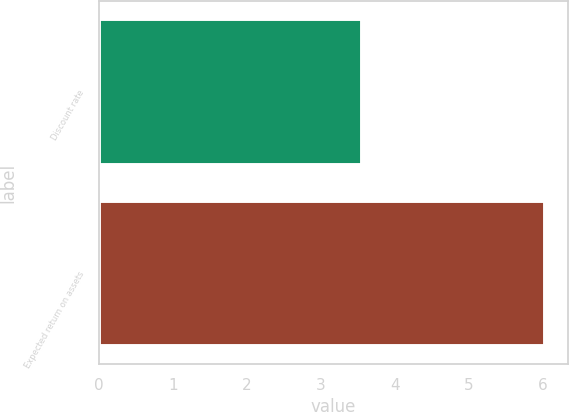Convert chart. <chart><loc_0><loc_0><loc_500><loc_500><bar_chart><fcel>Discount rate<fcel>Expected return on assets<nl><fcel>3.56<fcel>6.03<nl></chart> 